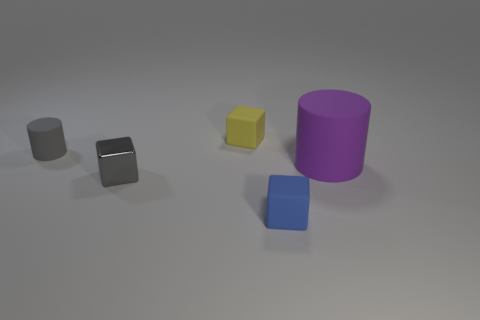What materials do the objects look like they're made from? The objects appear to have different materials. The silver cube resembles a metallic surface, likely metal. The yellow cube might be plastic based on its gloss and the shadow it casts. The blue cube could also be plastic, but with a matte finish. The purple cylinder has a surface that appears smooth and reflective, suggesting it might be painted metal or plastic. 